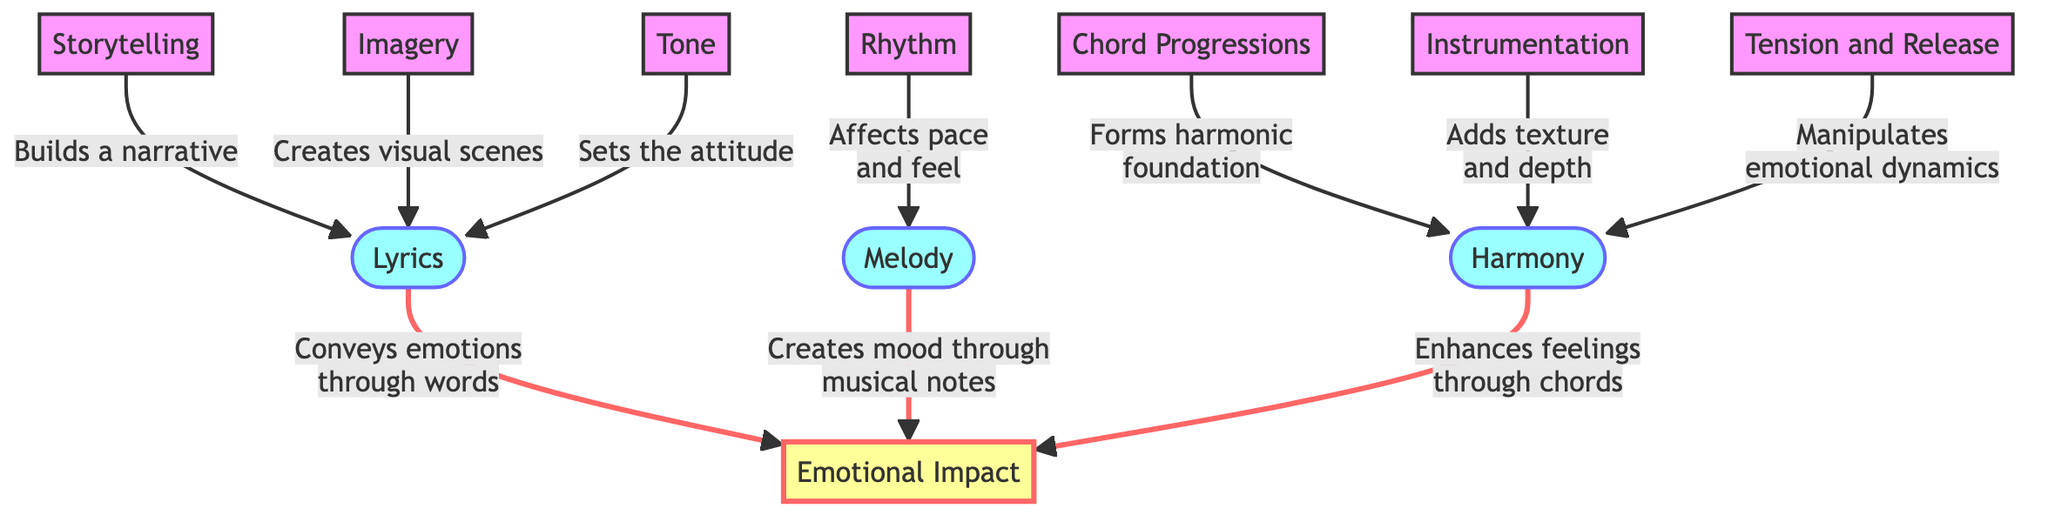What is the total number of nodes in the diagram? Counting the nodes listed, there are 10 elements including Lyrics, Melody, Harmony, Emotional Impact, Storytelling, Imagery, Tone, Chord Progressions, Instrumentation, and Rhythm.
Answer: 10 How many edges are there connecting elements to Emotional Impact? There are three edges directed towards Emotional Impact from Lyrics, Melody, and Harmony, indicating their contribution to the emotional effect on listeners.
Answer: 3 What does Harmony enhance according to the diagram? The edge from Harmony points to Emotional Impact, which states that it enhances feelings through chords.
Answer: Feelings Which element is described as "Creates visual scenes"? The edge from Imagery points to Lyrics, stating its role in creating visual scenes within the context of a song's lyrics.
Answer: Imagery What role does Rhythm play in the overall structure? The edge from Rhythm to Melody states that it affects the pace and feel, indicating its influence on how the melody is experienced by listeners.
Answer: Affects pace and feel Explain the connection between Chord Progressions and Harmony. The arrow from Chord Progressions to Harmony indicates that it forms the harmonic foundation, essential for building the song’s harmony. Hence, it is a fundamental aspect of how harmony is structured in music.
Answer: Forms harmonic foundation What influences the emotional dynamics in music? The edge from Tension and Release points to Harmony, specifying that it manipulates emotional dynamics, suggesting its crucial role in shaping how listeners experience the song emotionally.
Answer: Manipulates emotional dynamics Which element conveys emotions through words? The direct edge from Lyrics to Emotional Impact clearly indicates that Lyrics are responsible for conveying emotions through the words of the song.
Answer: Lyrics What builds a narrative in a song's lyrics? The edge directed from Storytelling to Lyrics mentions that it builds a narrative, highlighting its importance in song structure.
Answer: Storytelling 